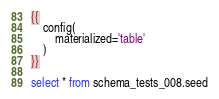<code> <loc_0><loc_0><loc_500><loc_500><_SQL_>
{{
    config(
        materialized='table'
    )
}}

select * from schema_tests_008.seed
</code> 